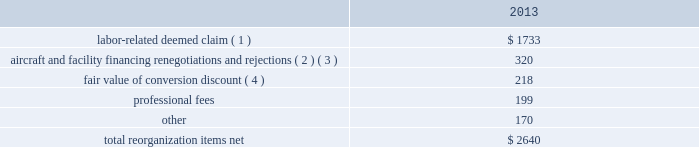Table of contents interest expense , net of capitalized interest decreased $ 129 million , or 18.1% ( 18.1 % ) , in 2014 from the 2013 period primarily due to a $ 63 million decrease in special charges recognized period-over-period as further described below , as well as refinancing activities that resulted in $ 65 million less interest expense recognized in 2014 .
In 2014 , american recognized $ 29 million of special charges relating to non-cash interest accretion on bankruptcy settlement obligations .
In 2013 , american recognized $ 48 million of special charges relating to post-petition interest expense on unsecured obligations pursuant to the plan and penalty interest related to american 2019s 10.5% ( 10.5 % ) secured notes and 7.50% ( 7.50 % ) senior secured notes .
In addition , in 2013 american recorded special charges of $ 44 million for debt extinguishment costs incurred as a result of the repayment of certain aircraft secured indebtedness , including cash interest charges and non-cash write offs of unamortized debt issuance costs .
As a result of the 2013 refinancing activities and the early extinguishment of american 2019s 7.50% ( 7.50 % ) senior secured notes in 2014 , american recognized $ 65 million less interest expense in 2014 as compared to the 2013 period .
Other nonoperating expense , net of $ 153 million in 2014 consisted principally of net foreign currency losses of $ 92 million and early debt extinguishment charges of $ 48 million .
Other nonoperating expense , net of $ 84 million in 2013 consisted principally of net foreign currency losses of $ 55 million and early debt extinguishment charges of $ 29 million .
Other nonoperating expense , net increased $ 69 million , or 81.0% ( 81.0 % ) , during 2014 primarily due to special charges recognized as a result of early debt extinguishment and an increase in foreign currency losses driven by the strengthening of the u.s .
Dollar in foreign currency transactions , principally in latin american markets .
American recorded a $ 43 million special charge for venezuelan foreign currency losses in 2014 .
See part ii , item 7a .
Quantitative and qualitative disclosures about market risk for further discussion of our cash held in venezuelan bolivars .
In addition , american 2019s nonoperating special items included $ 48 million in special charges in the 2014 primarily related to the early extinguishment of american 2019s 7.50% ( 7.50 % ) senior secured notes and other indebtedness .
Reorganization items , net reorganization items refer to revenues , expenses ( including professional fees ) , realized gains and losses and provisions for losses that are realized or incurred as a direct result of the chapter 11 cases .
The table summarizes the components included in reorganization items , net on american 2019s consolidated statement of operations for the year ended december 31 , 2013 ( in millions ) : .
( 1 ) in exchange for employees 2019 contributions to the successful reorganization , including agreeing to reductions in pay and benefits , american agreed in the plan to provide each employee group a deemed claim , which was used to provide a distribution of a portion of the equity of the reorganized entity to those employees .
Each employee group received a deemed claim amount based upon a portion of the value of cost savings provided by that group through reductions to pay and benefits as well as through certain work rule changes .
The total value of this deemed claim was approximately $ 1.7 billion .
( 2 ) amounts include allowed claims ( claims approved by the bankruptcy court ) and estimated allowed claims relating to ( i ) the rejection or modification of financings related to aircraft and ( ii ) entry of orders treated as unsecured claims with respect to facility agreements supporting certain issuances of special facility revenue bonds .
The debtors recorded an estimated claim associated with the rejection or modification of a financing or facility agreement when the applicable motion was filed with the bankruptcy court to reject or modify .
In 2013 what was the percent of the professional fees as part of the total re-organization costs? 
Rationale: the percent is the amount divided by the total amount multiply by 100
Computations: (199 / 2640)
Answer: 0.07538. 